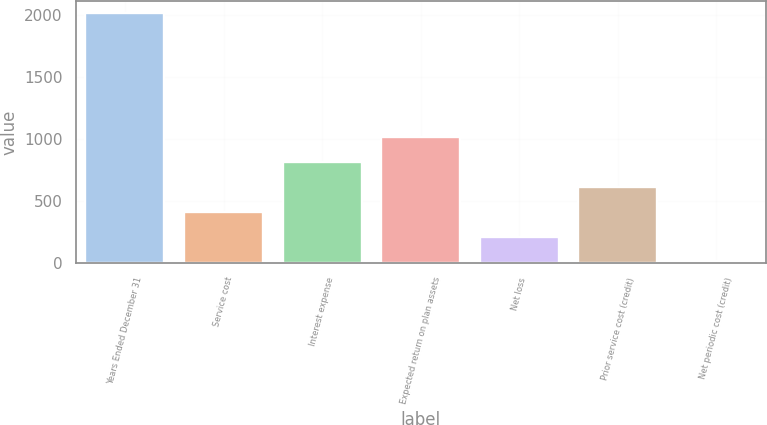Convert chart. <chart><loc_0><loc_0><loc_500><loc_500><bar_chart><fcel>Years Ended December 31<fcel>Service cost<fcel>Interest expense<fcel>Expected return on plan assets<fcel>Net loss<fcel>Prior service cost (credit)<fcel>Net periodic cost (credit)<nl><fcel>2013<fcel>412.2<fcel>812.4<fcel>1012.5<fcel>212.1<fcel>612.3<fcel>12<nl></chart> 